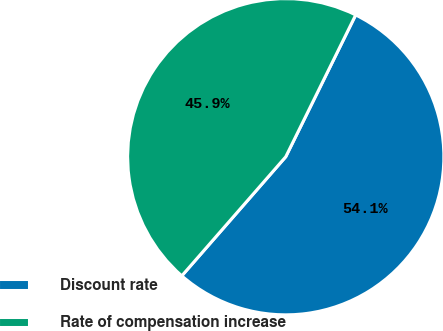Convert chart to OTSL. <chart><loc_0><loc_0><loc_500><loc_500><pie_chart><fcel>Discount rate<fcel>Rate of compensation increase<nl><fcel>54.13%<fcel>45.87%<nl></chart> 